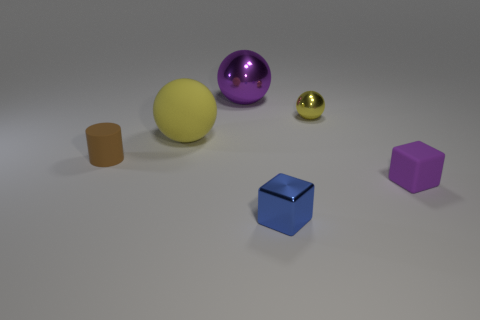Subtract all large matte balls. How many balls are left? 2 Subtract all purple balls. How many balls are left? 2 Add 4 tiny red metal things. How many objects exist? 10 Subtract 2 cubes. How many cubes are left? 0 Subtract all blocks. How many objects are left? 4 Subtract all blue cubes. How many purple balls are left? 1 Subtract 0 red balls. How many objects are left? 6 Subtract all green spheres. Subtract all gray cylinders. How many spheres are left? 3 Subtract all rubber balls. Subtract all small yellow balls. How many objects are left? 4 Add 6 yellow matte objects. How many yellow matte objects are left? 7 